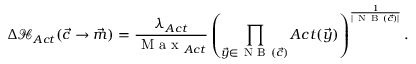<formula> <loc_0><loc_0><loc_500><loc_500>\Delta \mathcal { H } _ { A c t } ( \vec { c } \rightarrow \vec { m } ) = \frac { \lambda _ { A c t } } { M a x _ { A c t } } \left ( \prod _ { \vec { y } \in N B ( \vec { c } ) } A c t ( \vec { y } ) \right ) ^ { \frac { 1 } { | N B ( \vec { c } ) | } } .</formula> 